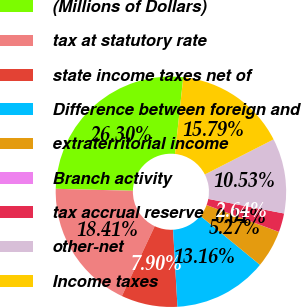<chart> <loc_0><loc_0><loc_500><loc_500><pie_chart><fcel>(Millions of Dollars)<fcel>tax at statutory rate<fcel>state income taxes net of<fcel>Difference between foreign and<fcel>extraterritorial income<fcel>Branch activity<fcel>tax accrual reserve<fcel>other-net<fcel>Income taxes<nl><fcel>26.31%<fcel>18.42%<fcel>7.9%<fcel>13.16%<fcel>5.27%<fcel>0.01%<fcel>2.64%<fcel>10.53%<fcel>15.79%<nl></chart> 